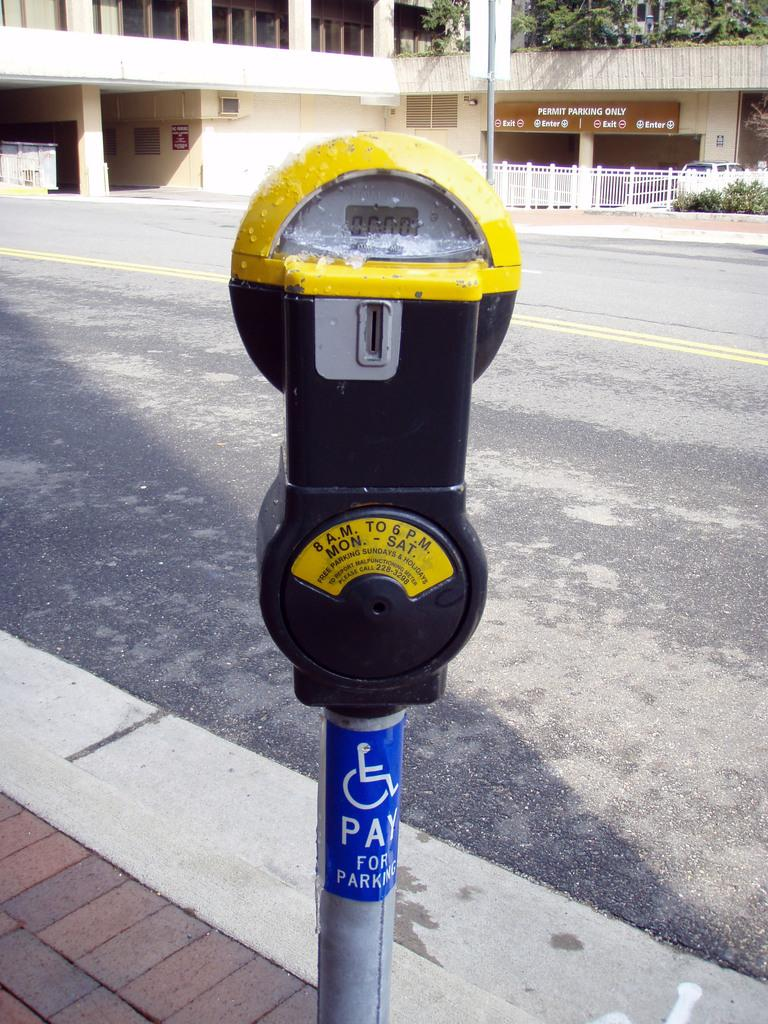Provide a one-sentence caption for the provided image. A parking meter that is active 8am to 6pm Mon-Sat. 